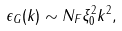<formula> <loc_0><loc_0><loc_500><loc_500>\epsilon _ { G } ( { k } ) \sim N _ { F } \xi _ { 0 } ^ { 2 } k ^ { 2 } ,</formula> 